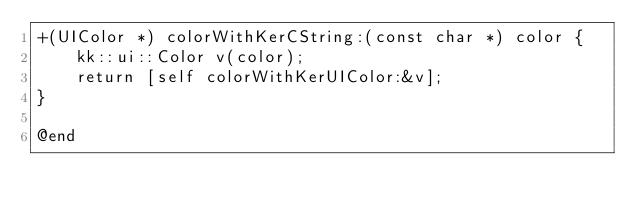Convert code to text. <code><loc_0><loc_0><loc_500><loc_500><_ObjectiveC_>+(UIColor *) colorWithKerCString:(const char *) color {
    kk::ui::Color v(color);
    return [self colorWithKerUIColor:&v];
}

@end
</code> 